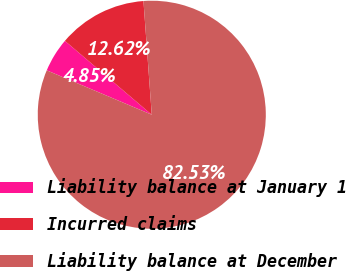<chart> <loc_0><loc_0><loc_500><loc_500><pie_chart><fcel>Liability balance at January 1<fcel>Incurred claims<fcel>Liability balance at December<nl><fcel>4.85%<fcel>12.62%<fcel>82.52%<nl></chart> 